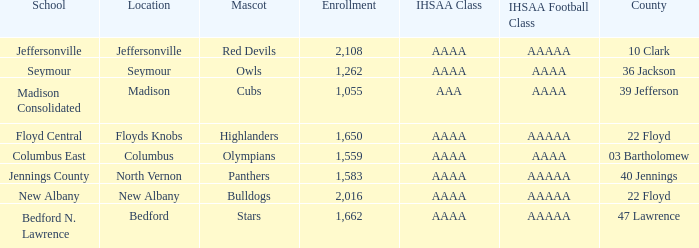What is bedford's mascot? Stars. 